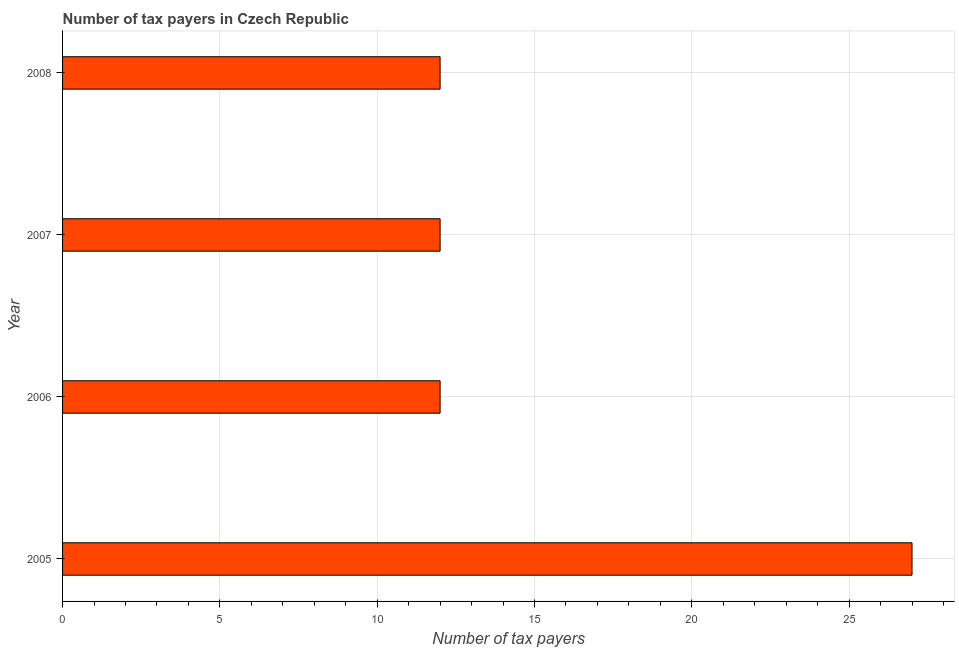What is the title of the graph?
Your answer should be very brief. Number of tax payers in Czech Republic. What is the label or title of the X-axis?
Offer a very short reply. Number of tax payers. Across all years, what is the maximum number of tax payers?
Your answer should be very brief. 27. Across all years, what is the minimum number of tax payers?
Give a very brief answer. 12. In which year was the number of tax payers maximum?
Give a very brief answer. 2005. In which year was the number of tax payers minimum?
Provide a succinct answer. 2006. What is the sum of the number of tax payers?
Offer a terse response. 63. What is the average number of tax payers per year?
Provide a succinct answer. 15. Do a majority of the years between 2007 and 2005 (inclusive) have number of tax payers greater than 5 ?
Offer a terse response. Yes. Is the sum of the number of tax payers in 2005 and 2006 greater than the maximum number of tax payers across all years?
Make the answer very short. Yes. How many years are there in the graph?
Keep it short and to the point. 4. What is the difference between two consecutive major ticks on the X-axis?
Your answer should be compact. 5. What is the Number of tax payers of 2005?
Make the answer very short. 27. What is the Number of tax payers in 2008?
Provide a short and direct response. 12. What is the difference between the Number of tax payers in 2005 and 2006?
Make the answer very short. 15. What is the difference between the Number of tax payers in 2005 and 2007?
Ensure brevity in your answer.  15. What is the difference between the Number of tax payers in 2007 and 2008?
Your answer should be compact. 0. What is the ratio of the Number of tax payers in 2005 to that in 2006?
Your answer should be compact. 2.25. What is the ratio of the Number of tax payers in 2005 to that in 2007?
Offer a terse response. 2.25. What is the ratio of the Number of tax payers in 2005 to that in 2008?
Ensure brevity in your answer.  2.25. What is the ratio of the Number of tax payers in 2006 to that in 2007?
Keep it short and to the point. 1. 